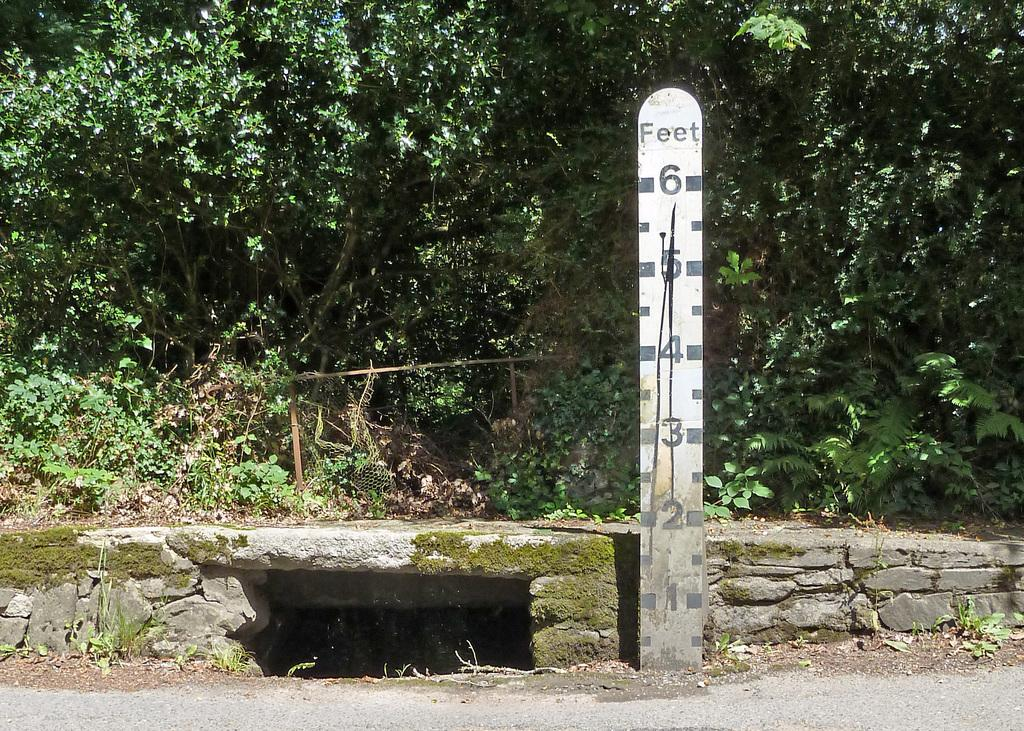What is the main object in the image? There is a wooden scale with length in the image. What is located behind the wooden scale? There is a small bridge behind the wooden scale. What type of natural environment is depicted in the image? There are many trees visible in the image. How many ants can be seen carrying a spade on the small bridge in the image? There are no ants or spades present in the image. What type of office furniture can be seen in the image? There is no office furniture present in the image. 